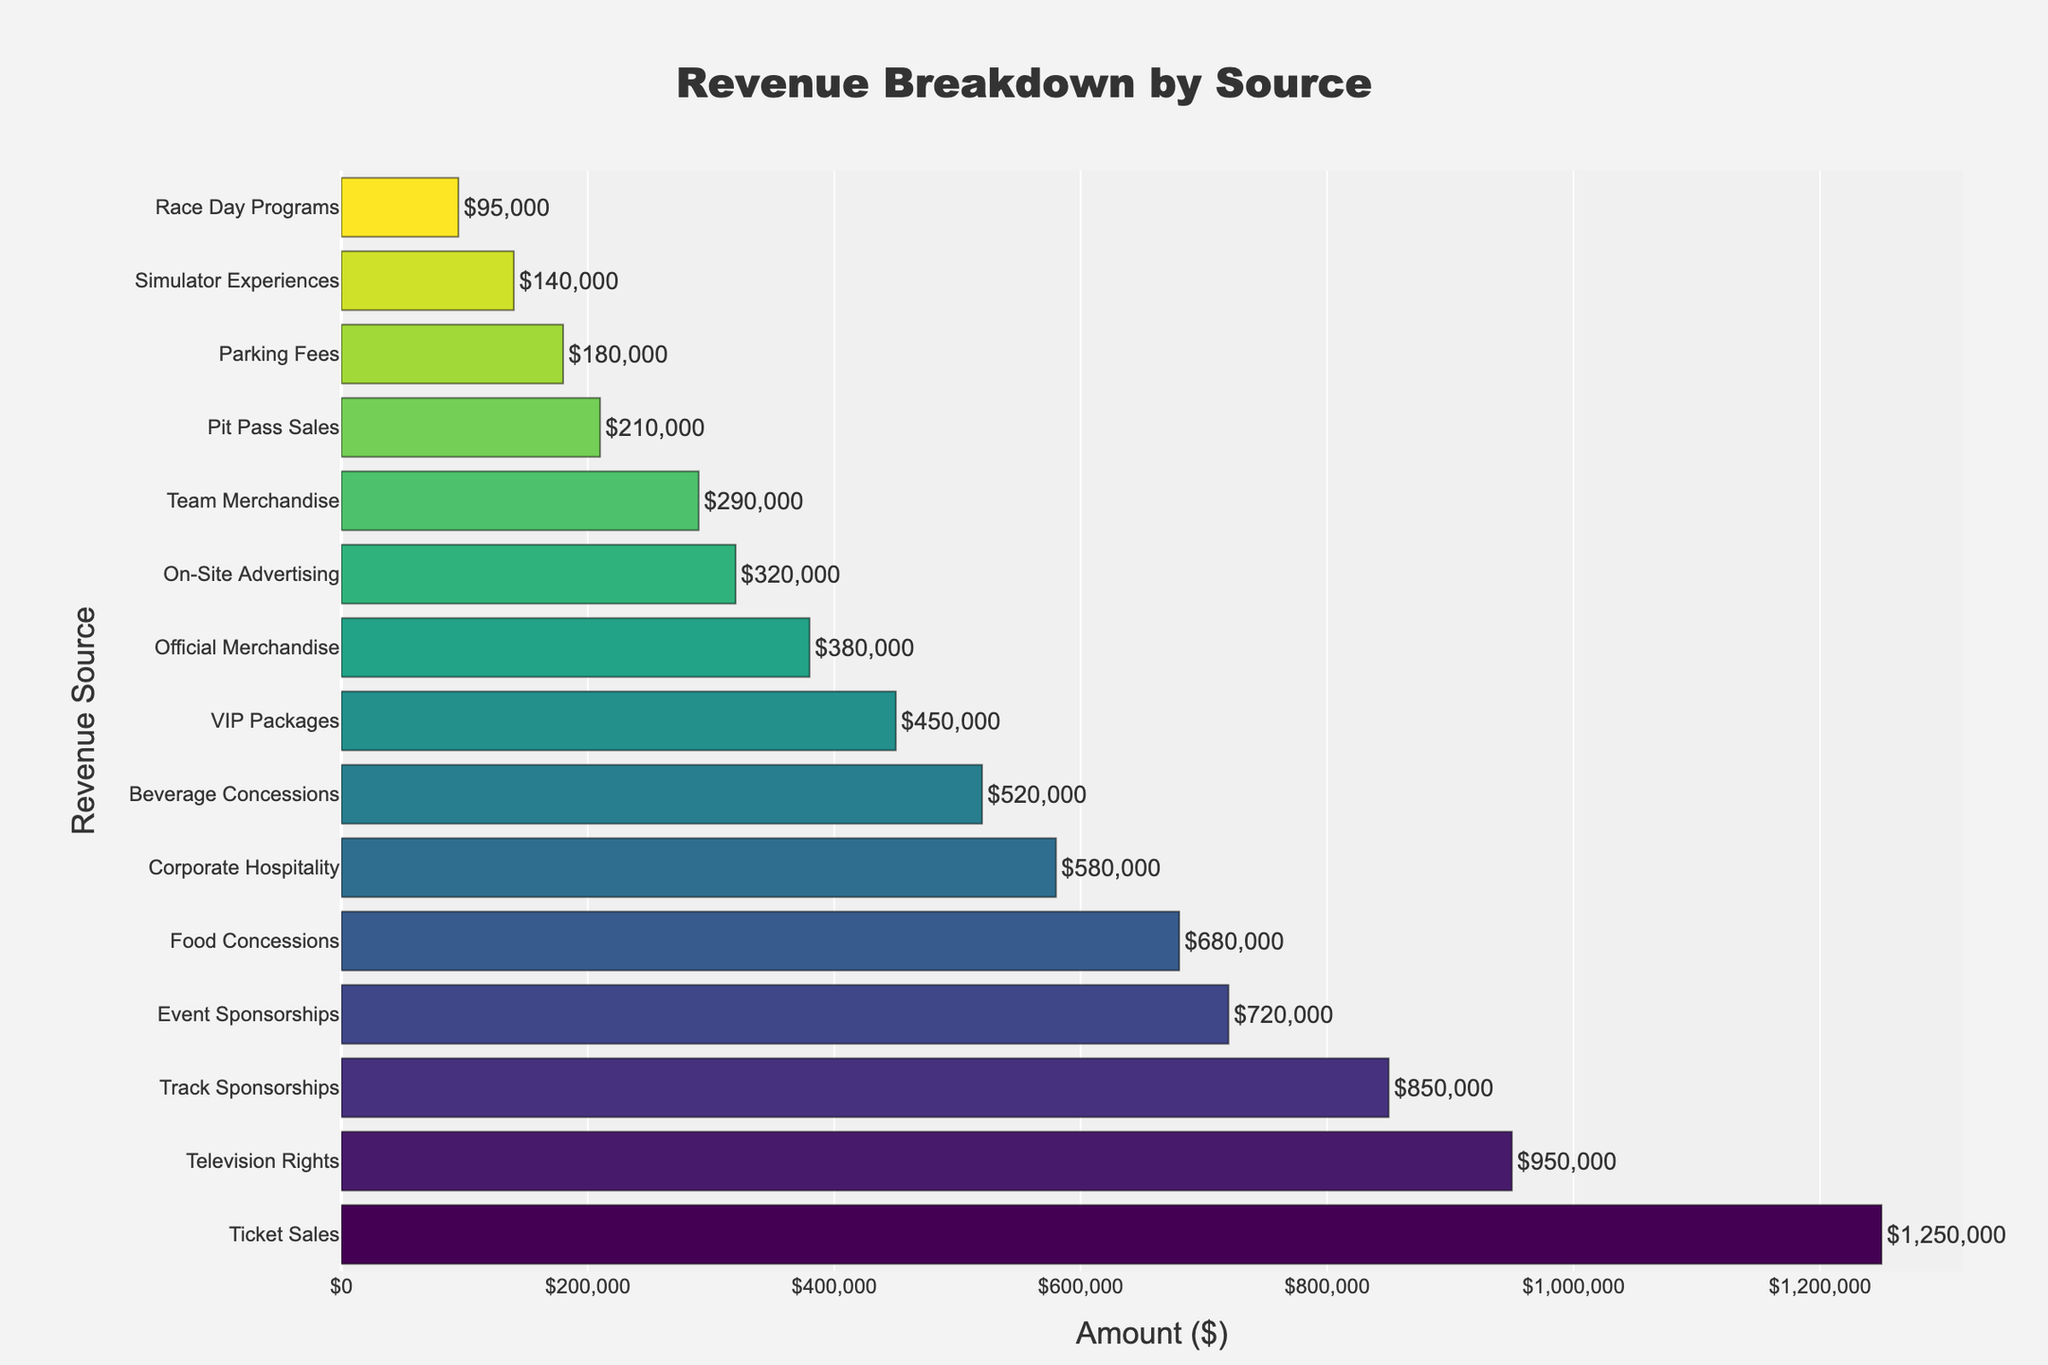What is the total revenue generated from all sources combined? Add up all the amounts from each revenue source: 1,250,000 (Ticket Sales) + 680,000 (Food Concessions) + 520,000 (Beverage Concessions) + 380,000 (Official Merchandise) + 290,000 (Team Merchandise) + 850,000 (Track Sponsorships) + 720,000 (Event Sponsorships) + 450,000 (VIP Packages) + 180,000 (Parking Fees) + 950,000 (Television Rights) + 320,000 (On-Site Advertising) + 95,000 (Race Day Programs) + 140,000 (Simulator Experiences) + 210,000 (Pit Pass Sales) + 580,000 (Corporate Hospitality) = 7,615,000
Answer: 7,615,000 Which revenue source generates the highest revenue? The bar representing "Ticket Sales" is the longest, indicating the highest revenue at $1,250,000
Answer: Ticket Sales How much more revenue does "Television Rights" generate compared to "Track Sponsorships"? Find the amounts for "Television Rights" ($950,000) and "Track Sponsorships" ($850,000), then subtract the latter from the former: 950,000 - 850,000 = 100,000
Answer: 100,000 What is the average revenue from "Concessions" (Food and Beverage)? First, find the sums of Food Concessions ($680,000) and Beverage Concessions ($520,000), then calculate the average: (680,000 + 520,000) / 2 = 600,000
Answer: 600,000 Which revenue source has the lowest contribution? The bar representing "Race Day Programs" is the shortest, indicating the lowest revenue at $95,000
Answer: Race Day Programs How much revenue is generated from all types of "Sponsorships" combined? Add the revenue from "Track Sponsorships" ($850,000) and "Event Sponsorships" ($720,000): 850,000 + 720,000 = 1,570,000
Answer: 1,570,000 What is the difference in revenue between "VIP Packages" and "Corporate Hospitality"? Find the amounts for "VIP Packages" ($450,000) and "Corporate Hospitality" ($580,000), then subtract the former from the latter: 580,000 - 450,000 = 130,000
Answer: 130,000 Which generates more revenue, "Official Merchandise" or "Team Merchandise"? Compare the revenue amounts for "Official Merchandise" ($380,000) and "Team Merchandise" ($290,000); "Official Merchandise" generates more.
Answer: Official Merchandise 